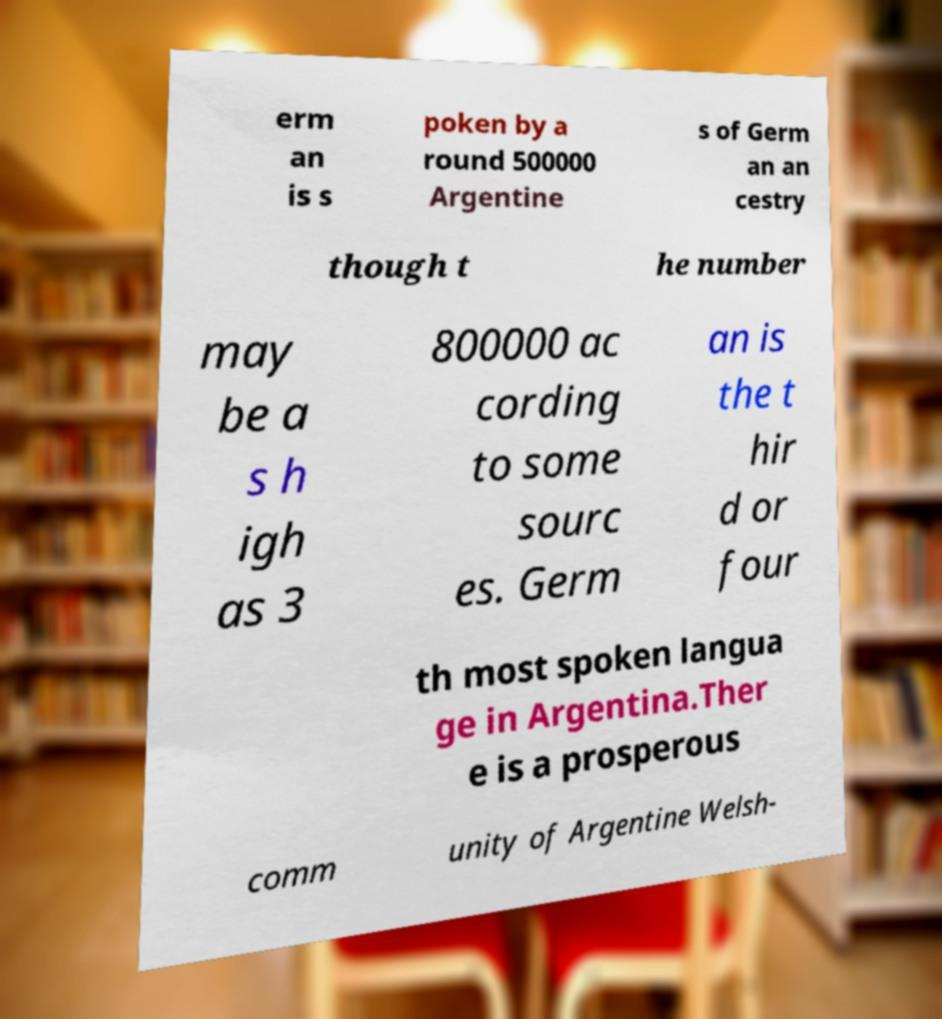Please read and relay the text visible in this image. What does it say? erm an is s poken by a round 500000 Argentine s of Germ an an cestry though t he number may be a s h igh as 3 800000 ac cording to some sourc es. Germ an is the t hir d or four th most spoken langua ge in Argentina.Ther e is a prosperous comm unity of Argentine Welsh- 